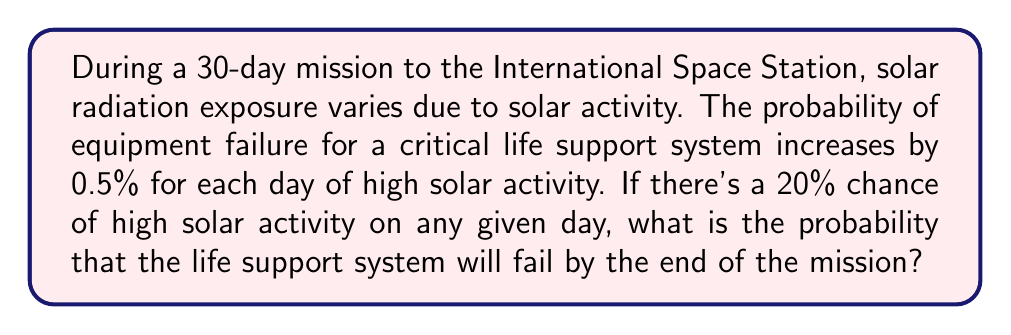Give your solution to this math problem. Let's approach this step-by-step:

1) First, we need to calculate the probability of the system not failing on a given day:
   - On a normal day: $P(\text{not fail}) = 1$
   - On a high solar activity day: $P(\text{not fail}) = 1 - 0.005 = 0.995$

2) The probability of a day being a high solar activity day is 0.2 (20%)

3) For any given day, the probability of the system not failing is:
   $P(\text{not fail for one day}) = 0.8 \times 1 + 0.2 \times 0.995 = 0.999$

4) For the system to not fail over 30 days, it must not fail each day:
   $P(\text{not fail for 30 days}) = (0.999)^{30}$

5) Therefore, the probability of failure by the end of the mission is:
   $P(\text{fail by end of mission}) = 1 - (0.999)^{30}$

6) Calculating this:
   $P(\text{fail by end of mission}) = 1 - (0.999)^{30} \approx 0.0296$
Answer: $0.0296$ or $2.96\%$ 